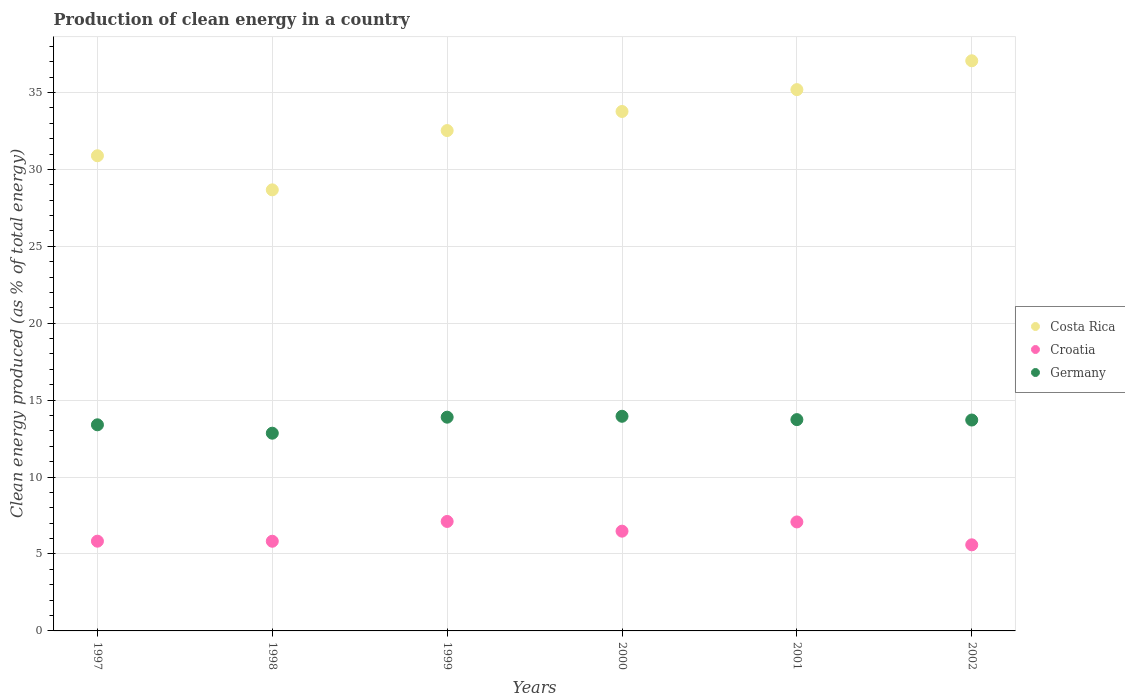How many different coloured dotlines are there?
Make the answer very short. 3. Is the number of dotlines equal to the number of legend labels?
Your response must be concise. Yes. What is the percentage of clean energy produced in Costa Rica in 1999?
Keep it short and to the point. 32.52. Across all years, what is the maximum percentage of clean energy produced in Croatia?
Offer a very short reply. 7.12. Across all years, what is the minimum percentage of clean energy produced in Germany?
Keep it short and to the point. 12.85. In which year was the percentage of clean energy produced in Croatia minimum?
Offer a very short reply. 2002. What is the total percentage of clean energy produced in Germany in the graph?
Provide a succinct answer. 81.54. What is the difference between the percentage of clean energy produced in Germany in 1998 and that in 2002?
Ensure brevity in your answer.  -0.86. What is the difference between the percentage of clean energy produced in Germany in 1998 and the percentage of clean energy produced in Croatia in 1997?
Offer a terse response. 7.02. What is the average percentage of clean energy produced in Croatia per year?
Your answer should be compact. 6.32. In the year 1997, what is the difference between the percentage of clean energy produced in Croatia and percentage of clean energy produced in Germany?
Keep it short and to the point. -7.56. In how many years, is the percentage of clean energy produced in Costa Rica greater than 37 %?
Provide a succinct answer. 1. What is the ratio of the percentage of clean energy produced in Germany in 1998 to that in 2001?
Ensure brevity in your answer.  0.94. Is the difference between the percentage of clean energy produced in Croatia in 1999 and 2001 greater than the difference between the percentage of clean energy produced in Germany in 1999 and 2001?
Keep it short and to the point. No. What is the difference between the highest and the second highest percentage of clean energy produced in Germany?
Ensure brevity in your answer.  0.06. What is the difference between the highest and the lowest percentage of clean energy produced in Germany?
Ensure brevity in your answer.  1.1. In how many years, is the percentage of clean energy produced in Croatia greater than the average percentage of clean energy produced in Croatia taken over all years?
Offer a very short reply. 3. Is the sum of the percentage of clean energy produced in Germany in 1998 and 2002 greater than the maximum percentage of clean energy produced in Croatia across all years?
Offer a terse response. Yes. Is it the case that in every year, the sum of the percentage of clean energy produced in Germany and percentage of clean energy produced in Croatia  is greater than the percentage of clean energy produced in Costa Rica?
Your answer should be compact. No. Is the percentage of clean energy produced in Croatia strictly less than the percentage of clean energy produced in Costa Rica over the years?
Keep it short and to the point. Yes. How many years are there in the graph?
Offer a very short reply. 6. What is the difference between two consecutive major ticks on the Y-axis?
Ensure brevity in your answer.  5. How are the legend labels stacked?
Your answer should be compact. Vertical. What is the title of the graph?
Offer a very short reply. Production of clean energy in a country. Does "Jordan" appear as one of the legend labels in the graph?
Give a very brief answer. No. What is the label or title of the X-axis?
Your response must be concise. Years. What is the label or title of the Y-axis?
Keep it short and to the point. Clean energy produced (as % of total energy). What is the Clean energy produced (as % of total energy) of Costa Rica in 1997?
Provide a short and direct response. 30.89. What is the Clean energy produced (as % of total energy) in Croatia in 1997?
Your answer should be compact. 5.83. What is the Clean energy produced (as % of total energy) of Germany in 1997?
Your answer should be compact. 13.4. What is the Clean energy produced (as % of total energy) in Costa Rica in 1998?
Your answer should be compact. 28.67. What is the Clean energy produced (as % of total energy) of Croatia in 1998?
Provide a short and direct response. 5.83. What is the Clean energy produced (as % of total energy) in Germany in 1998?
Your answer should be very brief. 12.85. What is the Clean energy produced (as % of total energy) of Costa Rica in 1999?
Provide a short and direct response. 32.52. What is the Clean energy produced (as % of total energy) of Croatia in 1999?
Give a very brief answer. 7.12. What is the Clean energy produced (as % of total energy) of Germany in 1999?
Offer a terse response. 13.89. What is the Clean energy produced (as % of total energy) of Costa Rica in 2000?
Offer a very short reply. 33.76. What is the Clean energy produced (as % of total energy) of Croatia in 2000?
Provide a short and direct response. 6.48. What is the Clean energy produced (as % of total energy) in Germany in 2000?
Give a very brief answer. 13.95. What is the Clean energy produced (as % of total energy) of Costa Rica in 2001?
Offer a terse response. 35.18. What is the Clean energy produced (as % of total energy) in Croatia in 2001?
Ensure brevity in your answer.  7.08. What is the Clean energy produced (as % of total energy) in Germany in 2001?
Provide a short and direct response. 13.73. What is the Clean energy produced (as % of total energy) of Costa Rica in 2002?
Your answer should be very brief. 37.06. What is the Clean energy produced (as % of total energy) in Croatia in 2002?
Your answer should be very brief. 5.6. What is the Clean energy produced (as % of total energy) of Germany in 2002?
Make the answer very short. 13.71. Across all years, what is the maximum Clean energy produced (as % of total energy) in Costa Rica?
Offer a terse response. 37.06. Across all years, what is the maximum Clean energy produced (as % of total energy) of Croatia?
Provide a short and direct response. 7.12. Across all years, what is the maximum Clean energy produced (as % of total energy) in Germany?
Ensure brevity in your answer.  13.95. Across all years, what is the minimum Clean energy produced (as % of total energy) of Costa Rica?
Your answer should be very brief. 28.67. Across all years, what is the minimum Clean energy produced (as % of total energy) in Croatia?
Provide a succinct answer. 5.6. Across all years, what is the minimum Clean energy produced (as % of total energy) in Germany?
Your answer should be very brief. 12.85. What is the total Clean energy produced (as % of total energy) in Costa Rica in the graph?
Your answer should be very brief. 198.09. What is the total Clean energy produced (as % of total energy) of Croatia in the graph?
Make the answer very short. 37.94. What is the total Clean energy produced (as % of total energy) in Germany in the graph?
Give a very brief answer. 81.54. What is the difference between the Clean energy produced (as % of total energy) of Costa Rica in 1997 and that in 1998?
Provide a succinct answer. 2.22. What is the difference between the Clean energy produced (as % of total energy) of Croatia in 1997 and that in 1998?
Offer a very short reply. 0. What is the difference between the Clean energy produced (as % of total energy) of Germany in 1997 and that in 1998?
Your response must be concise. 0.55. What is the difference between the Clean energy produced (as % of total energy) in Costa Rica in 1997 and that in 1999?
Give a very brief answer. -1.64. What is the difference between the Clean energy produced (as % of total energy) in Croatia in 1997 and that in 1999?
Provide a short and direct response. -1.28. What is the difference between the Clean energy produced (as % of total energy) of Germany in 1997 and that in 1999?
Keep it short and to the point. -0.5. What is the difference between the Clean energy produced (as % of total energy) in Costa Rica in 1997 and that in 2000?
Offer a very short reply. -2.88. What is the difference between the Clean energy produced (as % of total energy) of Croatia in 1997 and that in 2000?
Your answer should be compact. -0.65. What is the difference between the Clean energy produced (as % of total energy) of Germany in 1997 and that in 2000?
Provide a succinct answer. -0.55. What is the difference between the Clean energy produced (as % of total energy) in Costa Rica in 1997 and that in 2001?
Keep it short and to the point. -4.3. What is the difference between the Clean energy produced (as % of total energy) of Croatia in 1997 and that in 2001?
Offer a very short reply. -1.25. What is the difference between the Clean energy produced (as % of total energy) of Germany in 1997 and that in 2001?
Make the answer very short. -0.34. What is the difference between the Clean energy produced (as % of total energy) of Costa Rica in 1997 and that in 2002?
Give a very brief answer. -6.17. What is the difference between the Clean energy produced (as % of total energy) in Croatia in 1997 and that in 2002?
Your answer should be compact. 0.24. What is the difference between the Clean energy produced (as % of total energy) in Germany in 1997 and that in 2002?
Offer a terse response. -0.31. What is the difference between the Clean energy produced (as % of total energy) of Costa Rica in 1998 and that in 1999?
Give a very brief answer. -3.85. What is the difference between the Clean energy produced (as % of total energy) in Croatia in 1998 and that in 1999?
Keep it short and to the point. -1.29. What is the difference between the Clean energy produced (as % of total energy) of Germany in 1998 and that in 1999?
Your answer should be compact. -1.04. What is the difference between the Clean energy produced (as % of total energy) of Costa Rica in 1998 and that in 2000?
Give a very brief answer. -5.1. What is the difference between the Clean energy produced (as % of total energy) of Croatia in 1998 and that in 2000?
Offer a terse response. -0.66. What is the difference between the Clean energy produced (as % of total energy) in Germany in 1998 and that in 2000?
Offer a terse response. -1.1. What is the difference between the Clean energy produced (as % of total energy) in Costa Rica in 1998 and that in 2001?
Make the answer very short. -6.52. What is the difference between the Clean energy produced (as % of total energy) of Croatia in 1998 and that in 2001?
Offer a very short reply. -1.26. What is the difference between the Clean energy produced (as % of total energy) in Germany in 1998 and that in 2001?
Offer a very short reply. -0.88. What is the difference between the Clean energy produced (as % of total energy) of Costa Rica in 1998 and that in 2002?
Your response must be concise. -8.39. What is the difference between the Clean energy produced (as % of total energy) in Croatia in 1998 and that in 2002?
Your answer should be very brief. 0.23. What is the difference between the Clean energy produced (as % of total energy) of Germany in 1998 and that in 2002?
Ensure brevity in your answer.  -0.86. What is the difference between the Clean energy produced (as % of total energy) in Costa Rica in 1999 and that in 2000?
Provide a short and direct response. -1.24. What is the difference between the Clean energy produced (as % of total energy) of Croatia in 1999 and that in 2000?
Provide a short and direct response. 0.63. What is the difference between the Clean energy produced (as % of total energy) of Germany in 1999 and that in 2000?
Give a very brief answer. -0.06. What is the difference between the Clean energy produced (as % of total energy) in Costa Rica in 1999 and that in 2001?
Your answer should be compact. -2.66. What is the difference between the Clean energy produced (as % of total energy) of Croatia in 1999 and that in 2001?
Provide a succinct answer. 0.03. What is the difference between the Clean energy produced (as % of total energy) in Germany in 1999 and that in 2001?
Keep it short and to the point. 0.16. What is the difference between the Clean energy produced (as % of total energy) of Costa Rica in 1999 and that in 2002?
Provide a short and direct response. -4.54. What is the difference between the Clean energy produced (as % of total energy) in Croatia in 1999 and that in 2002?
Keep it short and to the point. 1.52. What is the difference between the Clean energy produced (as % of total energy) of Germany in 1999 and that in 2002?
Ensure brevity in your answer.  0.19. What is the difference between the Clean energy produced (as % of total energy) of Costa Rica in 2000 and that in 2001?
Make the answer very short. -1.42. What is the difference between the Clean energy produced (as % of total energy) of Croatia in 2000 and that in 2001?
Provide a short and direct response. -0.6. What is the difference between the Clean energy produced (as % of total energy) of Germany in 2000 and that in 2001?
Make the answer very short. 0.22. What is the difference between the Clean energy produced (as % of total energy) in Costa Rica in 2000 and that in 2002?
Offer a terse response. -3.3. What is the difference between the Clean energy produced (as % of total energy) of Croatia in 2000 and that in 2002?
Offer a very short reply. 0.89. What is the difference between the Clean energy produced (as % of total energy) of Germany in 2000 and that in 2002?
Provide a succinct answer. 0.24. What is the difference between the Clean energy produced (as % of total energy) in Costa Rica in 2001 and that in 2002?
Your answer should be compact. -1.88. What is the difference between the Clean energy produced (as % of total energy) of Croatia in 2001 and that in 2002?
Provide a succinct answer. 1.49. What is the difference between the Clean energy produced (as % of total energy) of Germany in 2001 and that in 2002?
Ensure brevity in your answer.  0.03. What is the difference between the Clean energy produced (as % of total energy) in Costa Rica in 1997 and the Clean energy produced (as % of total energy) in Croatia in 1998?
Ensure brevity in your answer.  25.06. What is the difference between the Clean energy produced (as % of total energy) in Costa Rica in 1997 and the Clean energy produced (as % of total energy) in Germany in 1998?
Provide a short and direct response. 18.03. What is the difference between the Clean energy produced (as % of total energy) of Croatia in 1997 and the Clean energy produced (as % of total energy) of Germany in 1998?
Offer a terse response. -7.02. What is the difference between the Clean energy produced (as % of total energy) in Costa Rica in 1997 and the Clean energy produced (as % of total energy) in Croatia in 1999?
Your answer should be very brief. 23.77. What is the difference between the Clean energy produced (as % of total energy) of Costa Rica in 1997 and the Clean energy produced (as % of total energy) of Germany in 1999?
Your response must be concise. 16.99. What is the difference between the Clean energy produced (as % of total energy) of Croatia in 1997 and the Clean energy produced (as % of total energy) of Germany in 1999?
Your answer should be very brief. -8.06. What is the difference between the Clean energy produced (as % of total energy) of Costa Rica in 1997 and the Clean energy produced (as % of total energy) of Croatia in 2000?
Give a very brief answer. 24.4. What is the difference between the Clean energy produced (as % of total energy) of Costa Rica in 1997 and the Clean energy produced (as % of total energy) of Germany in 2000?
Your answer should be compact. 16.93. What is the difference between the Clean energy produced (as % of total energy) in Croatia in 1997 and the Clean energy produced (as % of total energy) in Germany in 2000?
Ensure brevity in your answer.  -8.12. What is the difference between the Clean energy produced (as % of total energy) in Costa Rica in 1997 and the Clean energy produced (as % of total energy) in Croatia in 2001?
Ensure brevity in your answer.  23.8. What is the difference between the Clean energy produced (as % of total energy) in Costa Rica in 1997 and the Clean energy produced (as % of total energy) in Germany in 2001?
Your answer should be compact. 17.15. What is the difference between the Clean energy produced (as % of total energy) of Croatia in 1997 and the Clean energy produced (as % of total energy) of Germany in 2001?
Make the answer very short. -7.9. What is the difference between the Clean energy produced (as % of total energy) of Costa Rica in 1997 and the Clean energy produced (as % of total energy) of Croatia in 2002?
Your response must be concise. 25.29. What is the difference between the Clean energy produced (as % of total energy) in Costa Rica in 1997 and the Clean energy produced (as % of total energy) in Germany in 2002?
Make the answer very short. 17.18. What is the difference between the Clean energy produced (as % of total energy) in Croatia in 1997 and the Clean energy produced (as % of total energy) in Germany in 2002?
Your answer should be compact. -7.87. What is the difference between the Clean energy produced (as % of total energy) in Costa Rica in 1998 and the Clean energy produced (as % of total energy) in Croatia in 1999?
Your answer should be compact. 21.55. What is the difference between the Clean energy produced (as % of total energy) of Costa Rica in 1998 and the Clean energy produced (as % of total energy) of Germany in 1999?
Your answer should be compact. 14.78. What is the difference between the Clean energy produced (as % of total energy) of Croatia in 1998 and the Clean energy produced (as % of total energy) of Germany in 1999?
Offer a very short reply. -8.06. What is the difference between the Clean energy produced (as % of total energy) in Costa Rica in 1998 and the Clean energy produced (as % of total energy) in Croatia in 2000?
Your answer should be very brief. 22.18. What is the difference between the Clean energy produced (as % of total energy) in Costa Rica in 1998 and the Clean energy produced (as % of total energy) in Germany in 2000?
Your answer should be compact. 14.72. What is the difference between the Clean energy produced (as % of total energy) of Croatia in 1998 and the Clean energy produced (as % of total energy) of Germany in 2000?
Your response must be concise. -8.12. What is the difference between the Clean energy produced (as % of total energy) in Costa Rica in 1998 and the Clean energy produced (as % of total energy) in Croatia in 2001?
Your answer should be very brief. 21.59. What is the difference between the Clean energy produced (as % of total energy) in Costa Rica in 1998 and the Clean energy produced (as % of total energy) in Germany in 2001?
Provide a succinct answer. 14.93. What is the difference between the Clean energy produced (as % of total energy) of Croatia in 1998 and the Clean energy produced (as % of total energy) of Germany in 2001?
Provide a short and direct response. -7.91. What is the difference between the Clean energy produced (as % of total energy) in Costa Rica in 1998 and the Clean energy produced (as % of total energy) in Croatia in 2002?
Ensure brevity in your answer.  23.07. What is the difference between the Clean energy produced (as % of total energy) in Costa Rica in 1998 and the Clean energy produced (as % of total energy) in Germany in 2002?
Ensure brevity in your answer.  14.96. What is the difference between the Clean energy produced (as % of total energy) of Croatia in 1998 and the Clean energy produced (as % of total energy) of Germany in 2002?
Make the answer very short. -7.88. What is the difference between the Clean energy produced (as % of total energy) of Costa Rica in 1999 and the Clean energy produced (as % of total energy) of Croatia in 2000?
Provide a short and direct response. 26.04. What is the difference between the Clean energy produced (as % of total energy) of Costa Rica in 1999 and the Clean energy produced (as % of total energy) of Germany in 2000?
Offer a terse response. 18.57. What is the difference between the Clean energy produced (as % of total energy) of Croatia in 1999 and the Clean energy produced (as % of total energy) of Germany in 2000?
Offer a very short reply. -6.84. What is the difference between the Clean energy produced (as % of total energy) of Costa Rica in 1999 and the Clean energy produced (as % of total energy) of Croatia in 2001?
Your response must be concise. 25.44. What is the difference between the Clean energy produced (as % of total energy) of Costa Rica in 1999 and the Clean energy produced (as % of total energy) of Germany in 2001?
Provide a succinct answer. 18.79. What is the difference between the Clean energy produced (as % of total energy) of Croatia in 1999 and the Clean energy produced (as % of total energy) of Germany in 2001?
Give a very brief answer. -6.62. What is the difference between the Clean energy produced (as % of total energy) of Costa Rica in 1999 and the Clean energy produced (as % of total energy) of Croatia in 2002?
Give a very brief answer. 26.93. What is the difference between the Clean energy produced (as % of total energy) in Costa Rica in 1999 and the Clean energy produced (as % of total energy) in Germany in 2002?
Your response must be concise. 18.82. What is the difference between the Clean energy produced (as % of total energy) in Croatia in 1999 and the Clean energy produced (as % of total energy) in Germany in 2002?
Ensure brevity in your answer.  -6.59. What is the difference between the Clean energy produced (as % of total energy) in Costa Rica in 2000 and the Clean energy produced (as % of total energy) in Croatia in 2001?
Provide a succinct answer. 26.68. What is the difference between the Clean energy produced (as % of total energy) of Costa Rica in 2000 and the Clean energy produced (as % of total energy) of Germany in 2001?
Offer a very short reply. 20.03. What is the difference between the Clean energy produced (as % of total energy) of Croatia in 2000 and the Clean energy produced (as % of total energy) of Germany in 2001?
Give a very brief answer. -7.25. What is the difference between the Clean energy produced (as % of total energy) of Costa Rica in 2000 and the Clean energy produced (as % of total energy) of Croatia in 2002?
Keep it short and to the point. 28.17. What is the difference between the Clean energy produced (as % of total energy) in Costa Rica in 2000 and the Clean energy produced (as % of total energy) in Germany in 2002?
Your answer should be compact. 20.06. What is the difference between the Clean energy produced (as % of total energy) in Croatia in 2000 and the Clean energy produced (as % of total energy) in Germany in 2002?
Your response must be concise. -7.22. What is the difference between the Clean energy produced (as % of total energy) of Costa Rica in 2001 and the Clean energy produced (as % of total energy) of Croatia in 2002?
Your response must be concise. 29.59. What is the difference between the Clean energy produced (as % of total energy) of Costa Rica in 2001 and the Clean energy produced (as % of total energy) of Germany in 2002?
Provide a succinct answer. 21.48. What is the difference between the Clean energy produced (as % of total energy) of Croatia in 2001 and the Clean energy produced (as % of total energy) of Germany in 2002?
Offer a terse response. -6.62. What is the average Clean energy produced (as % of total energy) in Costa Rica per year?
Ensure brevity in your answer.  33.01. What is the average Clean energy produced (as % of total energy) in Croatia per year?
Make the answer very short. 6.32. What is the average Clean energy produced (as % of total energy) in Germany per year?
Your answer should be compact. 13.59. In the year 1997, what is the difference between the Clean energy produced (as % of total energy) of Costa Rica and Clean energy produced (as % of total energy) of Croatia?
Provide a short and direct response. 25.05. In the year 1997, what is the difference between the Clean energy produced (as % of total energy) of Costa Rica and Clean energy produced (as % of total energy) of Germany?
Ensure brevity in your answer.  17.49. In the year 1997, what is the difference between the Clean energy produced (as % of total energy) in Croatia and Clean energy produced (as % of total energy) in Germany?
Keep it short and to the point. -7.56. In the year 1998, what is the difference between the Clean energy produced (as % of total energy) of Costa Rica and Clean energy produced (as % of total energy) of Croatia?
Your response must be concise. 22.84. In the year 1998, what is the difference between the Clean energy produced (as % of total energy) in Costa Rica and Clean energy produced (as % of total energy) in Germany?
Make the answer very short. 15.82. In the year 1998, what is the difference between the Clean energy produced (as % of total energy) in Croatia and Clean energy produced (as % of total energy) in Germany?
Your answer should be very brief. -7.02. In the year 1999, what is the difference between the Clean energy produced (as % of total energy) of Costa Rica and Clean energy produced (as % of total energy) of Croatia?
Make the answer very short. 25.41. In the year 1999, what is the difference between the Clean energy produced (as % of total energy) in Costa Rica and Clean energy produced (as % of total energy) in Germany?
Give a very brief answer. 18.63. In the year 1999, what is the difference between the Clean energy produced (as % of total energy) in Croatia and Clean energy produced (as % of total energy) in Germany?
Your answer should be very brief. -6.78. In the year 2000, what is the difference between the Clean energy produced (as % of total energy) of Costa Rica and Clean energy produced (as % of total energy) of Croatia?
Keep it short and to the point. 27.28. In the year 2000, what is the difference between the Clean energy produced (as % of total energy) of Costa Rica and Clean energy produced (as % of total energy) of Germany?
Provide a succinct answer. 19.81. In the year 2000, what is the difference between the Clean energy produced (as % of total energy) in Croatia and Clean energy produced (as % of total energy) in Germany?
Your answer should be compact. -7.47. In the year 2001, what is the difference between the Clean energy produced (as % of total energy) in Costa Rica and Clean energy produced (as % of total energy) in Croatia?
Provide a succinct answer. 28.1. In the year 2001, what is the difference between the Clean energy produced (as % of total energy) of Costa Rica and Clean energy produced (as % of total energy) of Germany?
Provide a succinct answer. 21.45. In the year 2001, what is the difference between the Clean energy produced (as % of total energy) of Croatia and Clean energy produced (as % of total energy) of Germany?
Your answer should be compact. -6.65. In the year 2002, what is the difference between the Clean energy produced (as % of total energy) in Costa Rica and Clean energy produced (as % of total energy) in Croatia?
Your answer should be very brief. 31.46. In the year 2002, what is the difference between the Clean energy produced (as % of total energy) of Costa Rica and Clean energy produced (as % of total energy) of Germany?
Make the answer very short. 23.35. In the year 2002, what is the difference between the Clean energy produced (as % of total energy) in Croatia and Clean energy produced (as % of total energy) in Germany?
Provide a short and direct response. -8.11. What is the ratio of the Clean energy produced (as % of total energy) of Costa Rica in 1997 to that in 1998?
Your answer should be very brief. 1.08. What is the ratio of the Clean energy produced (as % of total energy) of Germany in 1997 to that in 1998?
Provide a succinct answer. 1.04. What is the ratio of the Clean energy produced (as % of total energy) of Costa Rica in 1997 to that in 1999?
Provide a succinct answer. 0.95. What is the ratio of the Clean energy produced (as % of total energy) in Croatia in 1997 to that in 1999?
Ensure brevity in your answer.  0.82. What is the ratio of the Clean energy produced (as % of total energy) of Germany in 1997 to that in 1999?
Give a very brief answer. 0.96. What is the ratio of the Clean energy produced (as % of total energy) in Costa Rica in 1997 to that in 2000?
Your response must be concise. 0.91. What is the ratio of the Clean energy produced (as % of total energy) in Croatia in 1997 to that in 2000?
Your answer should be very brief. 0.9. What is the ratio of the Clean energy produced (as % of total energy) of Germany in 1997 to that in 2000?
Offer a very short reply. 0.96. What is the ratio of the Clean energy produced (as % of total energy) in Costa Rica in 1997 to that in 2001?
Your answer should be very brief. 0.88. What is the ratio of the Clean energy produced (as % of total energy) of Croatia in 1997 to that in 2001?
Ensure brevity in your answer.  0.82. What is the ratio of the Clean energy produced (as % of total energy) of Germany in 1997 to that in 2001?
Keep it short and to the point. 0.98. What is the ratio of the Clean energy produced (as % of total energy) in Costa Rica in 1997 to that in 2002?
Offer a terse response. 0.83. What is the ratio of the Clean energy produced (as % of total energy) of Croatia in 1997 to that in 2002?
Provide a short and direct response. 1.04. What is the ratio of the Clean energy produced (as % of total energy) of Germany in 1997 to that in 2002?
Offer a very short reply. 0.98. What is the ratio of the Clean energy produced (as % of total energy) of Costa Rica in 1998 to that in 1999?
Your answer should be very brief. 0.88. What is the ratio of the Clean energy produced (as % of total energy) of Croatia in 1998 to that in 1999?
Offer a very short reply. 0.82. What is the ratio of the Clean energy produced (as % of total energy) in Germany in 1998 to that in 1999?
Your response must be concise. 0.93. What is the ratio of the Clean energy produced (as % of total energy) in Costa Rica in 1998 to that in 2000?
Your answer should be very brief. 0.85. What is the ratio of the Clean energy produced (as % of total energy) in Croatia in 1998 to that in 2000?
Offer a terse response. 0.9. What is the ratio of the Clean energy produced (as % of total energy) in Germany in 1998 to that in 2000?
Provide a short and direct response. 0.92. What is the ratio of the Clean energy produced (as % of total energy) of Costa Rica in 1998 to that in 2001?
Give a very brief answer. 0.81. What is the ratio of the Clean energy produced (as % of total energy) in Croatia in 1998 to that in 2001?
Give a very brief answer. 0.82. What is the ratio of the Clean energy produced (as % of total energy) in Germany in 1998 to that in 2001?
Provide a short and direct response. 0.94. What is the ratio of the Clean energy produced (as % of total energy) of Costa Rica in 1998 to that in 2002?
Your answer should be very brief. 0.77. What is the ratio of the Clean energy produced (as % of total energy) in Croatia in 1998 to that in 2002?
Give a very brief answer. 1.04. What is the ratio of the Clean energy produced (as % of total energy) of Costa Rica in 1999 to that in 2000?
Provide a short and direct response. 0.96. What is the ratio of the Clean energy produced (as % of total energy) in Croatia in 1999 to that in 2000?
Offer a very short reply. 1.1. What is the ratio of the Clean energy produced (as % of total energy) of Germany in 1999 to that in 2000?
Give a very brief answer. 1. What is the ratio of the Clean energy produced (as % of total energy) in Costa Rica in 1999 to that in 2001?
Provide a succinct answer. 0.92. What is the ratio of the Clean energy produced (as % of total energy) in Germany in 1999 to that in 2001?
Keep it short and to the point. 1.01. What is the ratio of the Clean energy produced (as % of total energy) of Costa Rica in 1999 to that in 2002?
Give a very brief answer. 0.88. What is the ratio of the Clean energy produced (as % of total energy) of Croatia in 1999 to that in 2002?
Offer a terse response. 1.27. What is the ratio of the Clean energy produced (as % of total energy) in Germany in 1999 to that in 2002?
Provide a succinct answer. 1.01. What is the ratio of the Clean energy produced (as % of total energy) in Costa Rica in 2000 to that in 2001?
Give a very brief answer. 0.96. What is the ratio of the Clean energy produced (as % of total energy) of Croatia in 2000 to that in 2001?
Make the answer very short. 0.92. What is the ratio of the Clean energy produced (as % of total energy) in Germany in 2000 to that in 2001?
Your answer should be very brief. 1.02. What is the ratio of the Clean energy produced (as % of total energy) of Costa Rica in 2000 to that in 2002?
Give a very brief answer. 0.91. What is the ratio of the Clean energy produced (as % of total energy) in Croatia in 2000 to that in 2002?
Offer a very short reply. 1.16. What is the ratio of the Clean energy produced (as % of total energy) in Germany in 2000 to that in 2002?
Provide a succinct answer. 1.02. What is the ratio of the Clean energy produced (as % of total energy) in Costa Rica in 2001 to that in 2002?
Provide a succinct answer. 0.95. What is the ratio of the Clean energy produced (as % of total energy) in Croatia in 2001 to that in 2002?
Give a very brief answer. 1.27. What is the difference between the highest and the second highest Clean energy produced (as % of total energy) of Costa Rica?
Your response must be concise. 1.88. What is the difference between the highest and the second highest Clean energy produced (as % of total energy) of Croatia?
Ensure brevity in your answer.  0.03. What is the difference between the highest and the second highest Clean energy produced (as % of total energy) in Germany?
Provide a short and direct response. 0.06. What is the difference between the highest and the lowest Clean energy produced (as % of total energy) in Costa Rica?
Your answer should be very brief. 8.39. What is the difference between the highest and the lowest Clean energy produced (as % of total energy) of Croatia?
Keep it short and to the point. 1.52. What is the difference between the highest and the lowest Clean energy produced (as % of total energy) of Germany?
Provide a short and direct response. 1.1. 